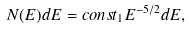Convert formula to latex. <formula><loc_0><loc_0><loc_500><loc_500>N ( E ) d E = c o n s t _ { 1 } E ^ { - 5 / 2 } d E ,</formula> 